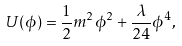Convert formula to latex. <formula><loc_0><loc_0><loc_500><loc_500>U ( \phi ) = { \frac { 1 } { 2 } } m ^ { 2 } \phi ^ { 2 } + { \frac { \lambda } { 2 4 } } \phi ^ { 4 } ,</formula> 